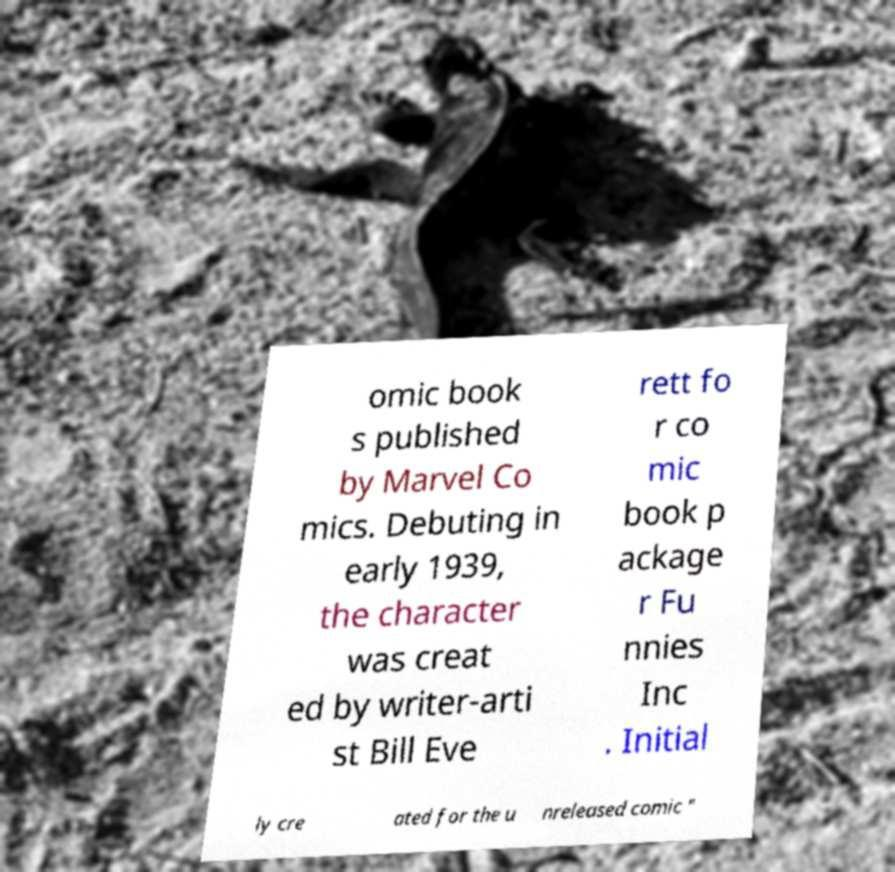There's text embedded in this image that I need extracted. Can you transcribe it verbatim? omic book s published by Marvel Co mics. Debuting in early 1939, the character was creat ed by writer-arti st Bill Eve rett fo r co mic book p ackage r Fu nnies Inc . Initial ly cre ated for the u nreleased comic " 